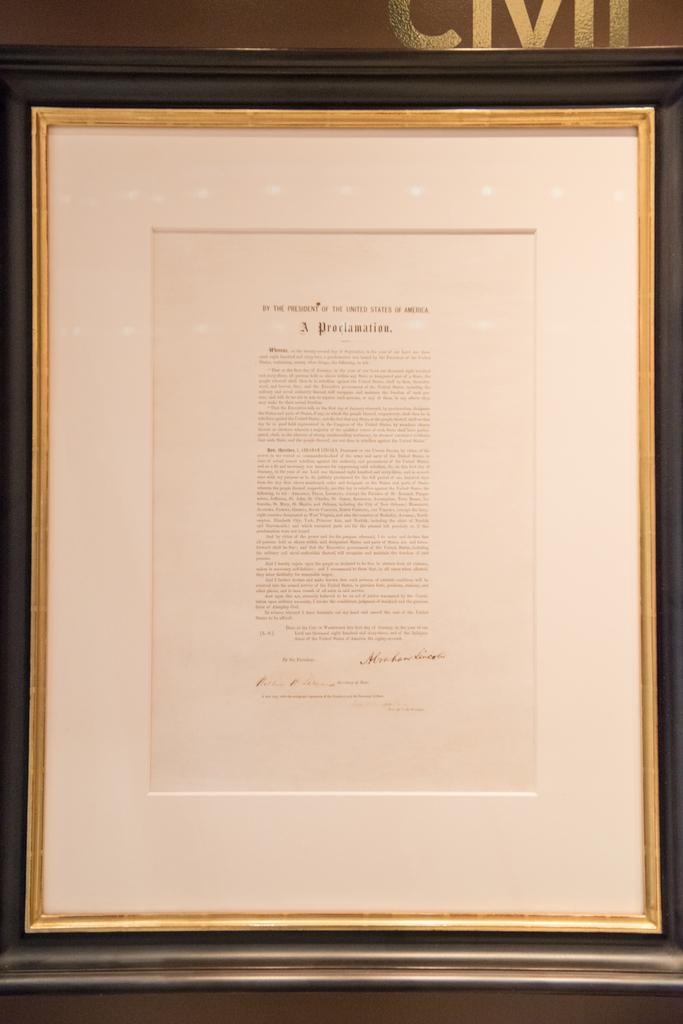<image>
Share a concise interpretation of the image provided. the word proclamation is on the front of a frame 